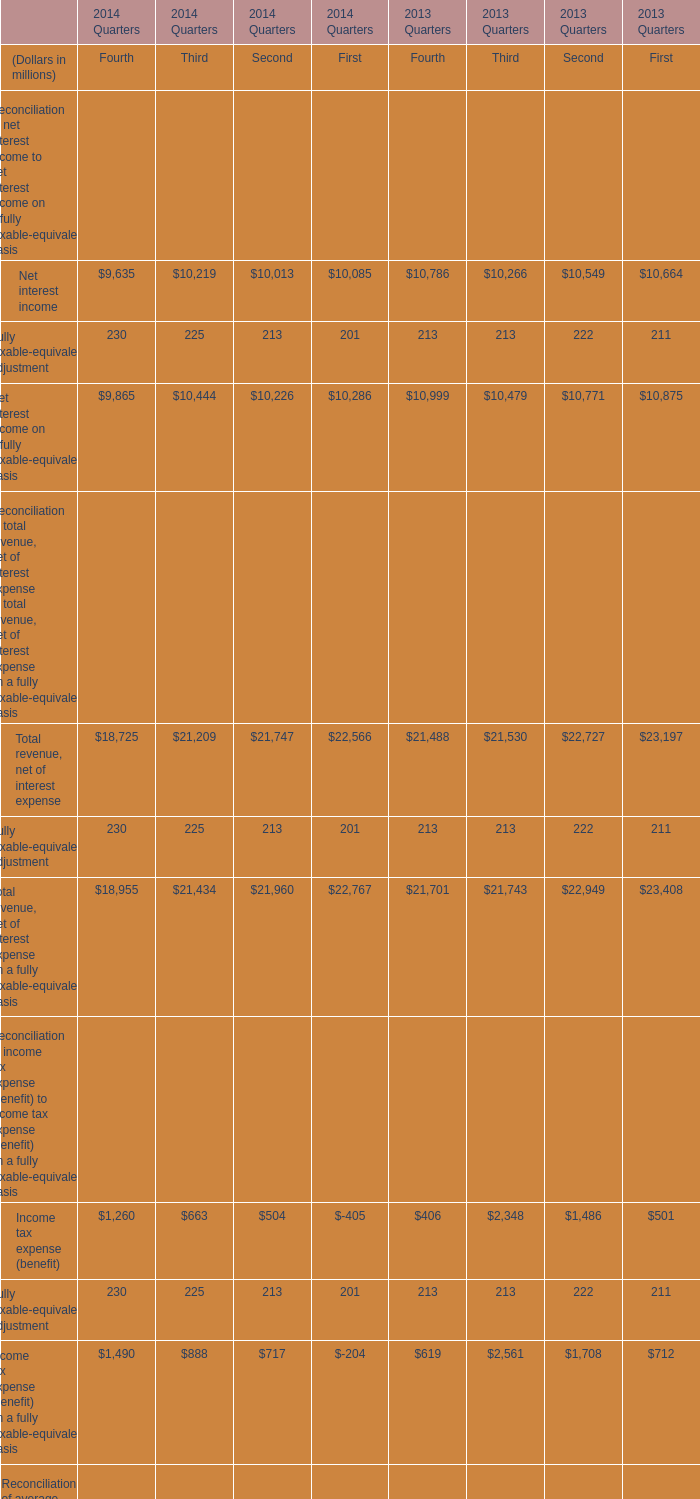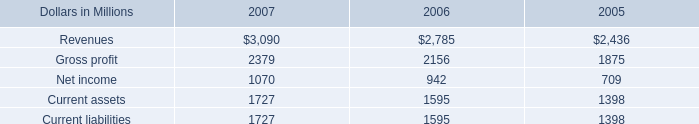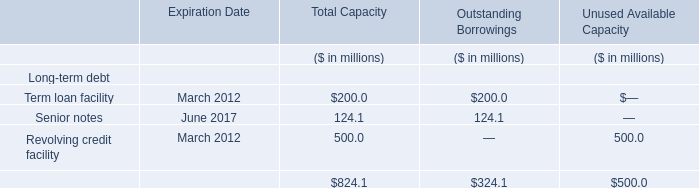What is the sum of Term loan facility for Total Capacity and Net income in 2006? (in million) 
Computations: (200 + 942)
Answer: 1142.0. 